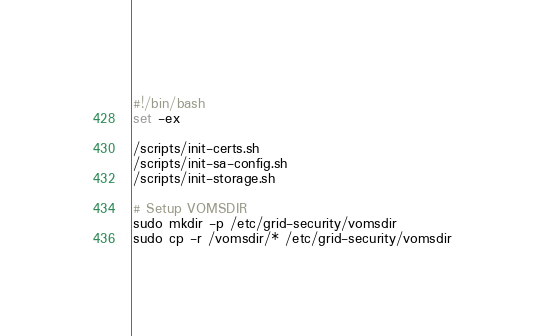Convert code to text. <code><loc_0><loc_0><loc_500><loc_500><_Bash_>#!/bin/bash
set -ex

/scripts/init-certs.sh
/scripts/init-sa-config.sh
/scripts/init-storage.sh

# Setup VOMSDIR
sudo mkdir -p /etc/grid-security/vomsdir
sudo cp -r /vomsdir/* /etc/grid-security/vomsdir
</code> 